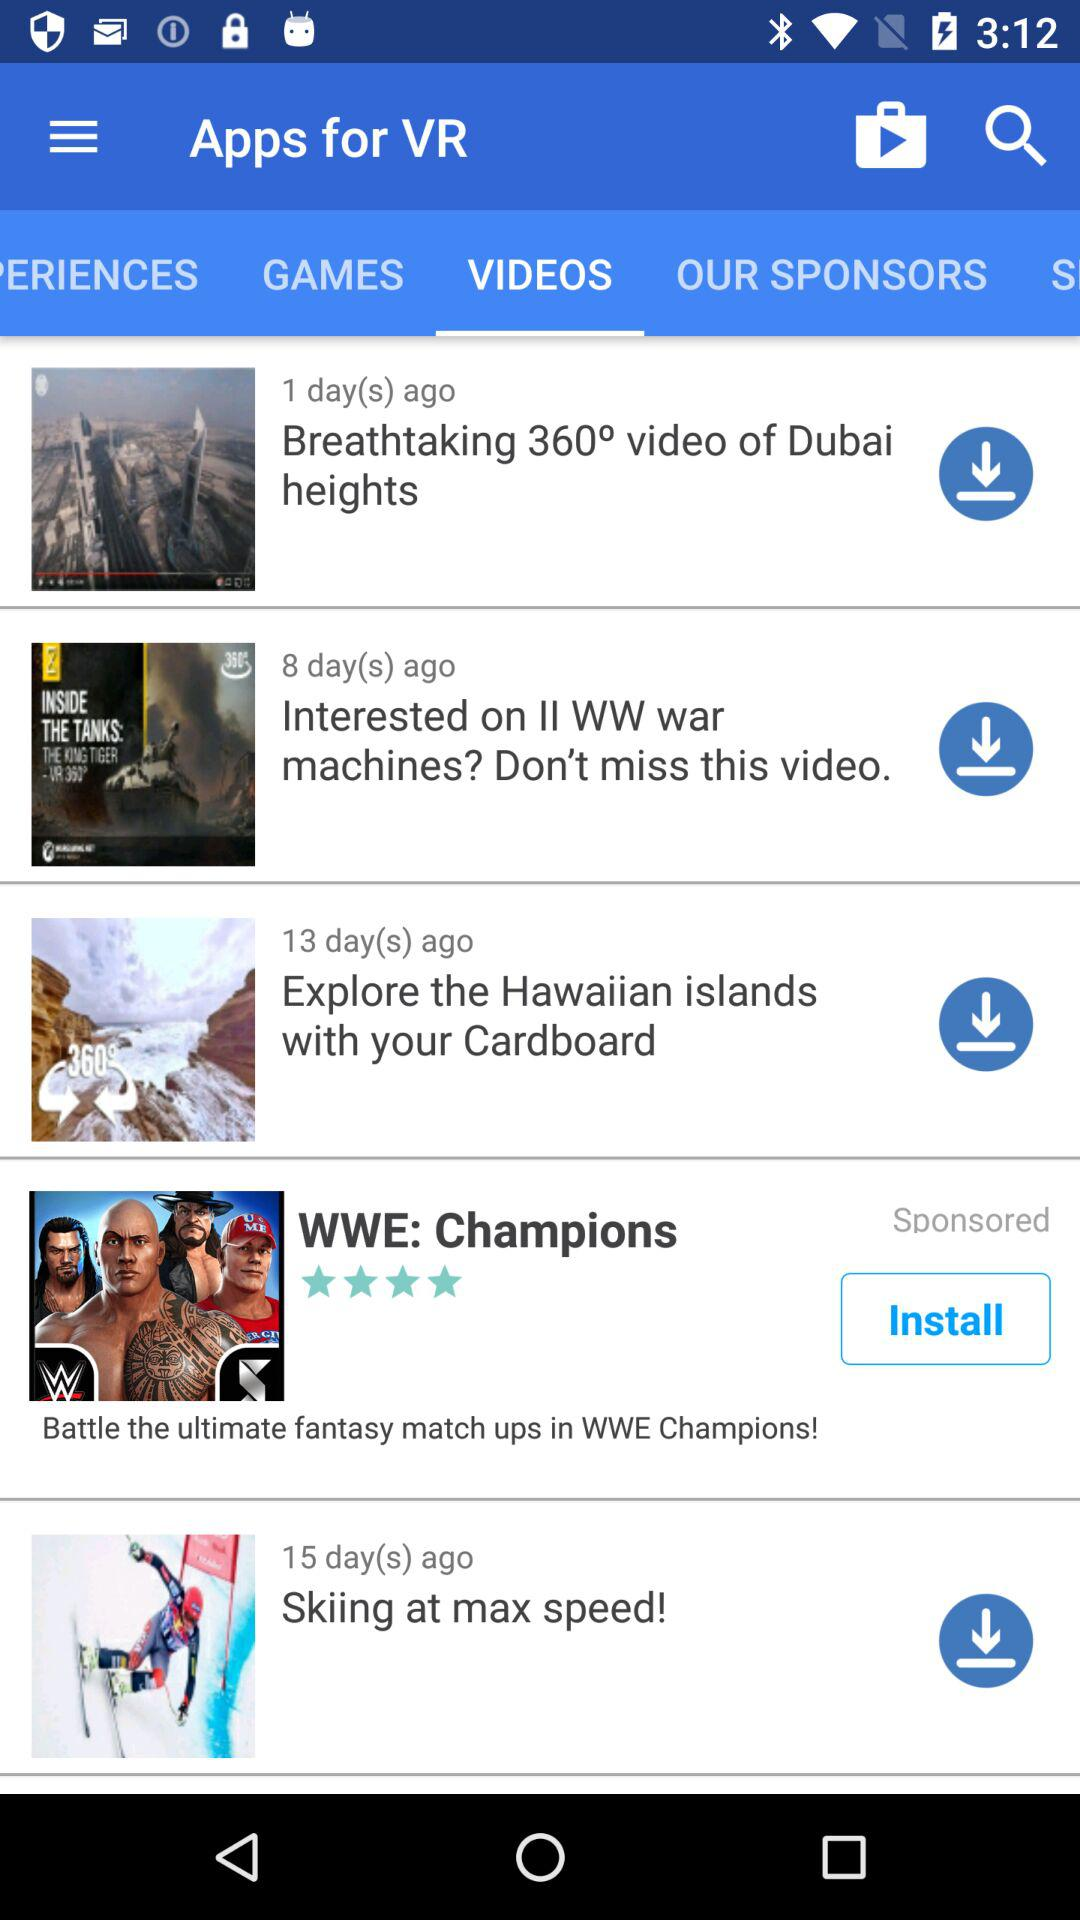When was "Skiing at max speed!" posted? "Skiing at max speed!" was posted 15 days ago. 